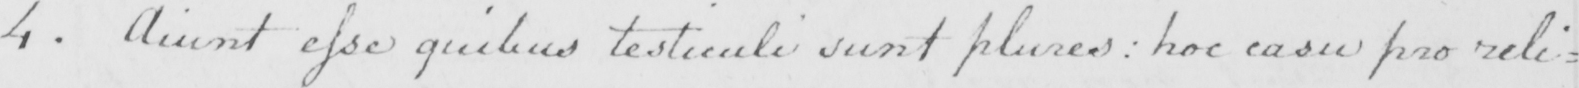Please provide the text content of this handwritten line. 4 . Aiunt esse quilus testiculi sunt plures :  hoc casu pro reli= 